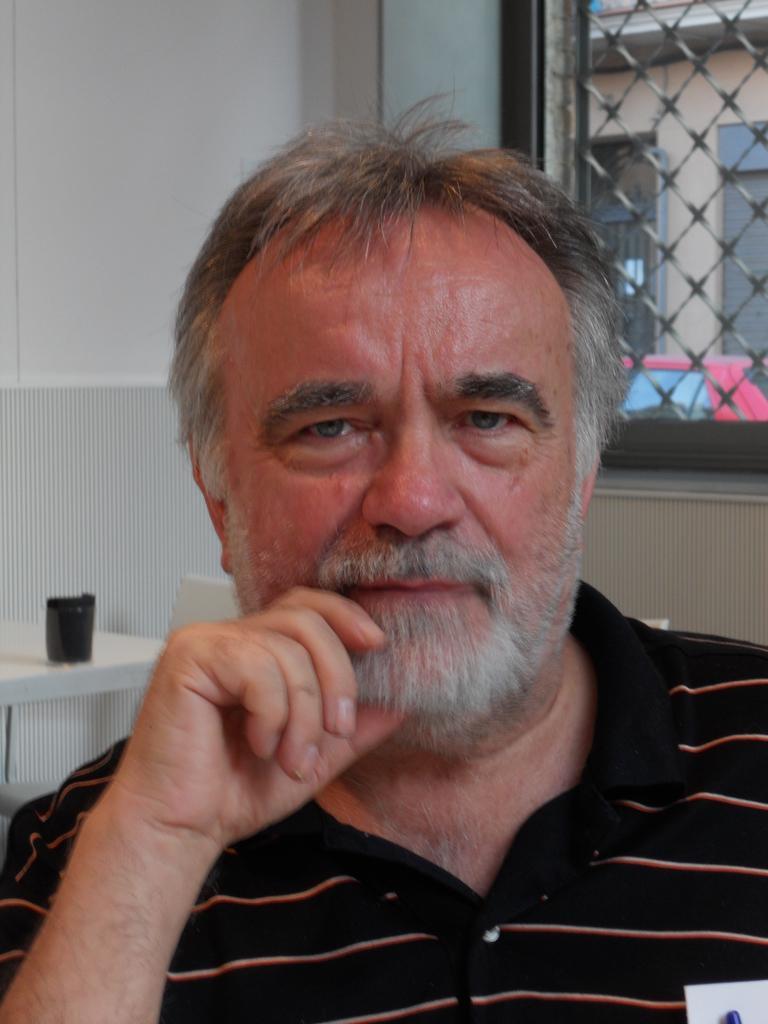How would you summarize this image in a sentence or two? The man in the front of the picture wearing black T-shirt is sitting on the chair. Beside him, we see a chair and a table on which cup is placed. Behind that, we see a white wall and a window from which we can see a red car and a building. This picture is clicked inside the room. 